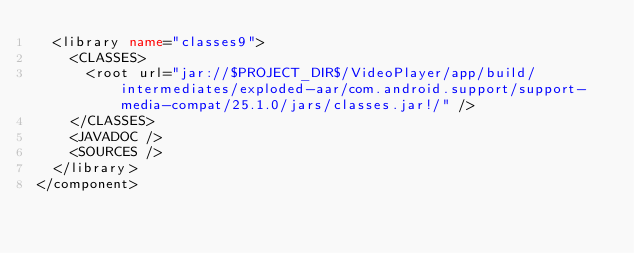Convert code to text. <code><loc_0><loc_0><loc_500><loc_500><_XML_>  <library name="classes9">
    <CLASSES>
      <root url="jar://$PROJECT_DIR$/VideoPlayer/app/build/intermediates/exploded-aar/com.android.support/support-media-compat/25.1.0/jars/classes.jar!/" />
    </CLASSES>
    <JAVADOC />
    <SOURCES />
  </library>
</component></code> 